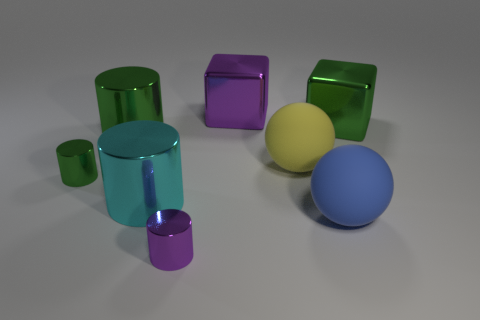Subtract all large cyan cylinders. How many cylinders are left? 3 Subtract all gray spheres. How many green cylinders are left? 2 Subtract 2 cylinders. How many cylinders are left? 2 Subtract all purple cylinders. How many cylinders are left? 3 Add 1 small green metal objects. How many objects exist? 9 Subtract all blocks. How many objects are left? 6 Subtract all large cyan cylinders. Subtract all tiny red metal cylinders. How many objects are left? 7 Add 4 tiny green cylinders. How many tiny green cylinders are left? 5 Add 5 big purple blocks. How many big purple blocks exist? 6 Subtract 0 green balls. How many objects are left? 8 